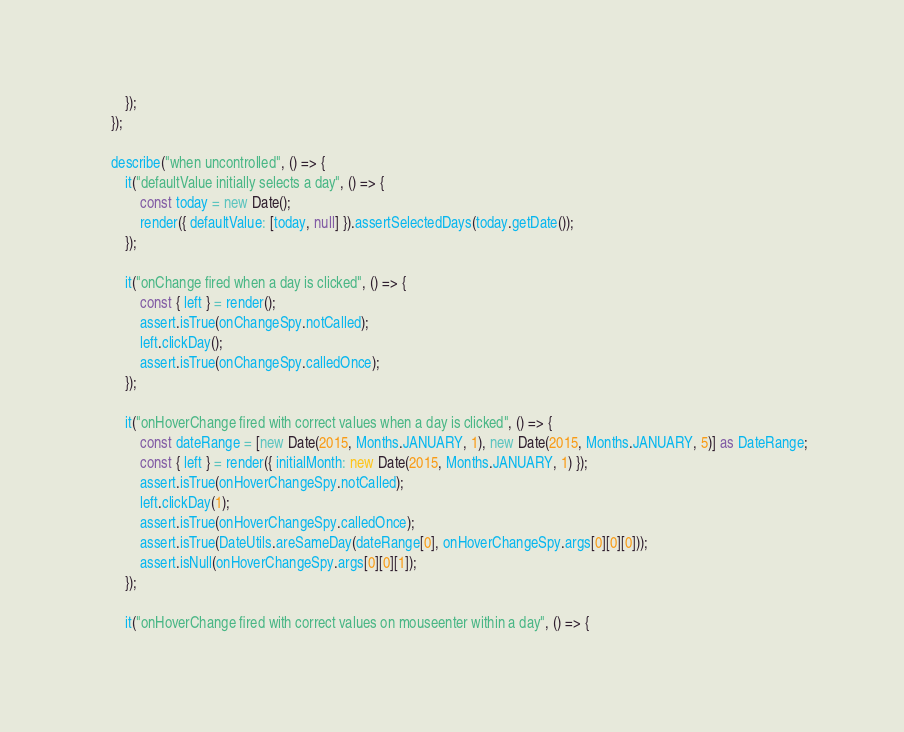<code> <loc_0><loc_0><loc_500><loc_500><_TypeScript_>        });
    });

    describe("when uncontrolled", () => {
        it("defaultValue initially selects a day", () => {
            const today = new Date();
            render({ defaultValue: [today, null] }).assertSelectedDays(today.getDate());
        });

        it("onChange fired when a day is clicked", () => {
            const { left } = render();
            assert.isTrue(onChangeSpy.notCalled);
            left.clickDay();
            assert.isTrue(onChangeSpy.calledOnce);
        });

        it("onHoverChange fired with correct values when a day is clicked", () => {
            const dateRange = [new Date(2015, Months.JANUARY, 1), new Date(2015, Months.JANUARY, 5)] as DateRange;
            const { left } = render({ initialMonth: new Date(2015, Months.JANUARY, 1) });
            assert.isTrue(onHoverChangeSpy.notCalled);
            left.clickDay(1);
            assert.isTrue(onHoverChangeSpy.calledOnce);
            assert.isTrue(DateUtils.areSameDay(dateRange[0], onHoverChangeSpy.args[0][0][0]));
            assert.isNull(onHoverChangeSpy.args[0][0][1]);
        });

        it("onHoverChange fired with correct values on mouseenter within a day", () => {</code> 